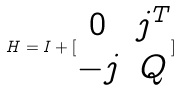Convert formula to latex. <formula><loc_0><loc_0><loc_500><loc_500>H = I + [ \begin{matrix} 0 & j ^ { T } \\ - j & Q \end{matrix} ]</formula> 